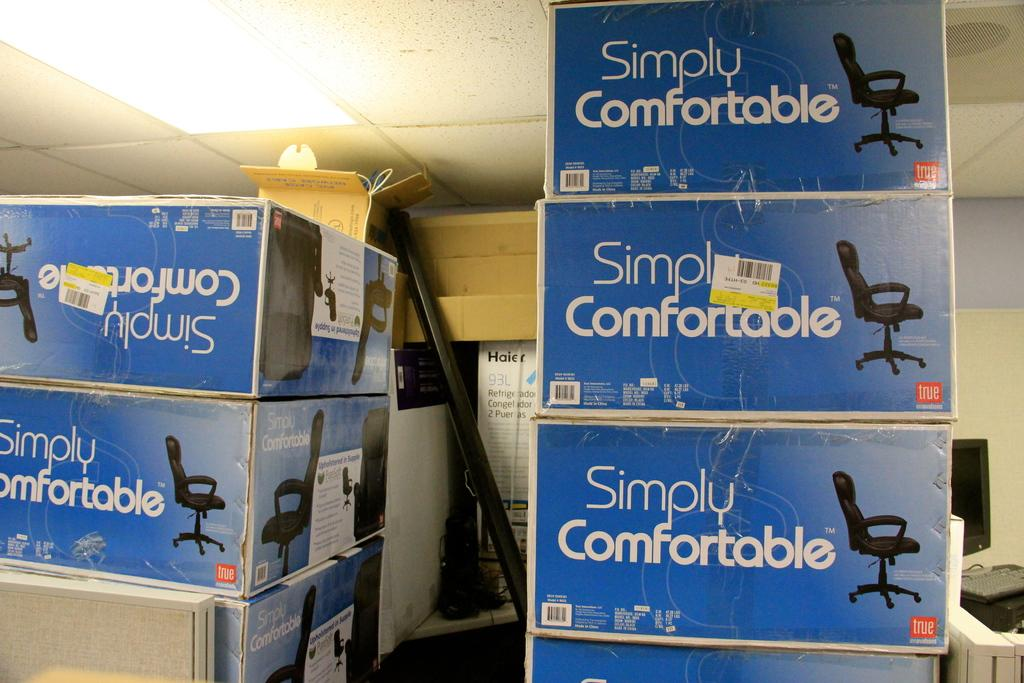Provide a one-sentence caption for the provided image. Simply Comfortable chairs in blue box's are stack high on one another. 